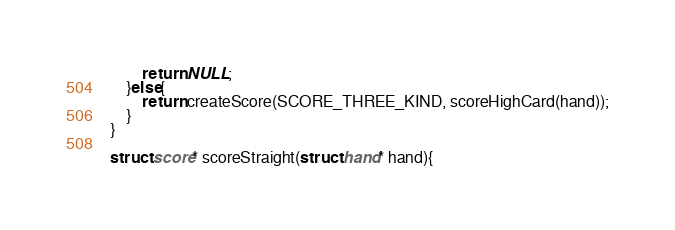<code> <loc_0><loc_0><loc_500><loc_500><_C++_>        return NULL;
    }else{
        return createScore(SCORE_THREE_KIND, scoreHighCard(hand));
    }
}

struct score* scoreStraight(struct hand* hand){</code> 